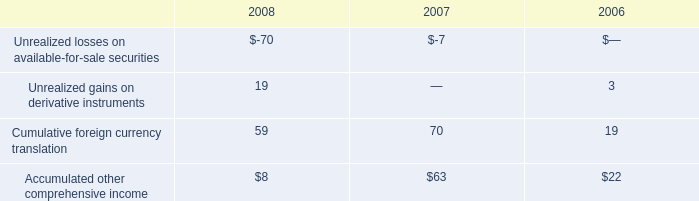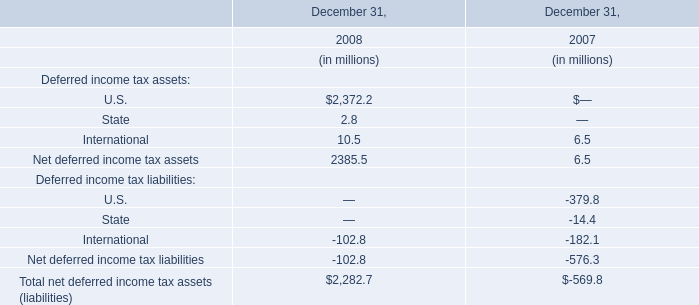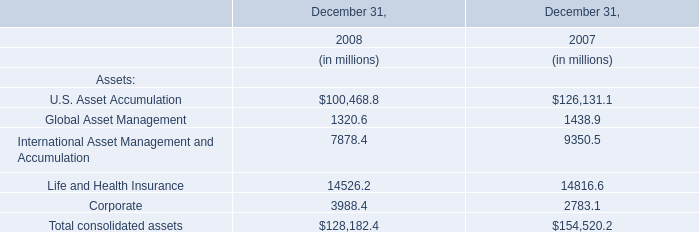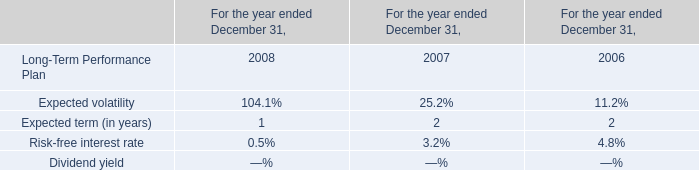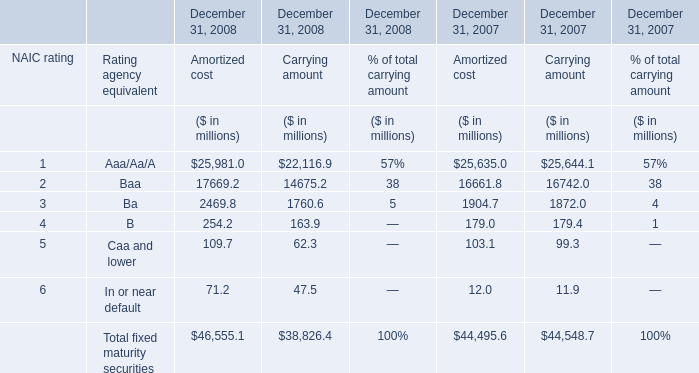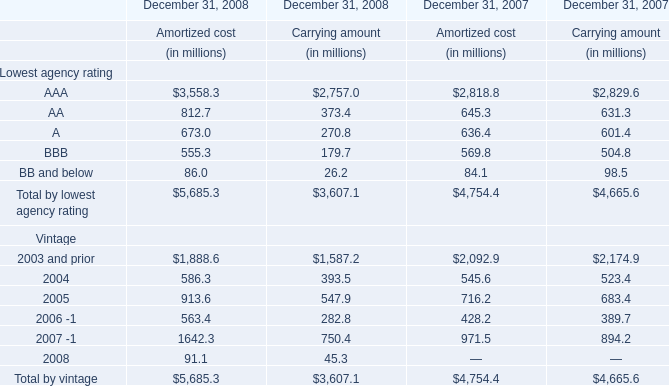What is the proportion of AAA of Lowest agency rating to the total in 2008 for Carrying amount ? 
Computations: (2757.0 / (3607.1 + 3607.1))
Answer: 0.38216. 